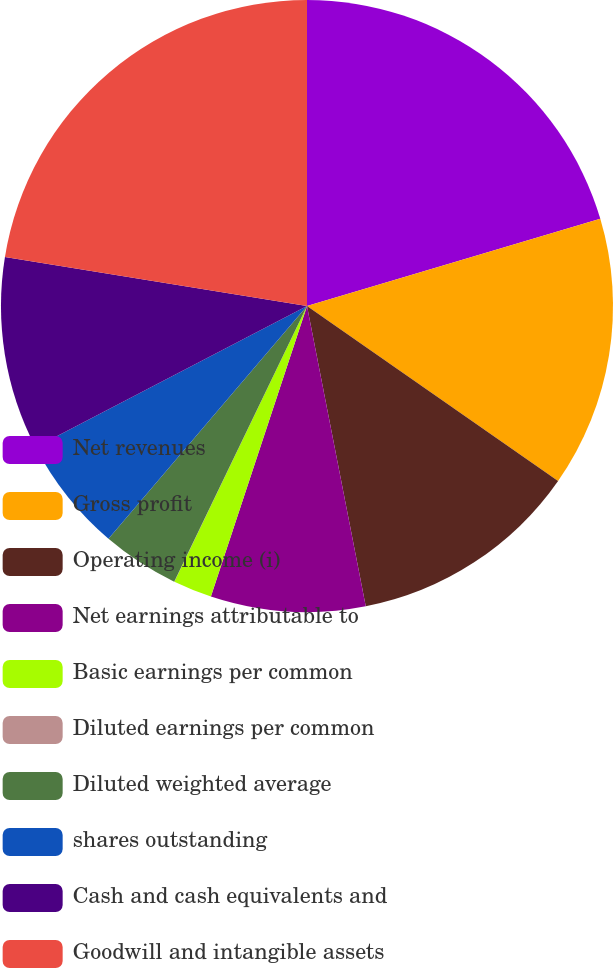Convert chart. <chart><loc_0><loc_0><loc_500><loc_500><pie_chart><fcel>Net revenues<fcel>Gross profit<fcel>Operating income (i)<fcel>Net earnings attributable to<fcel>Basic earnings per common<fcel>Diluted earnings per common<fcel>Diluted weighted average<fcel>shares outstanding<fcel>Cash and cash equivalents and<fcel>Goodwill and intangible assets<nl><fcel>20.4%<fcel>14.28%<fcel>12.24%<fcel>8.16%<fcel>2.05%<fcel>0.01%<fcel>4.09%<fcel>6.12%<fcel>10.2%<fcel>22.44%<nl></chart> 